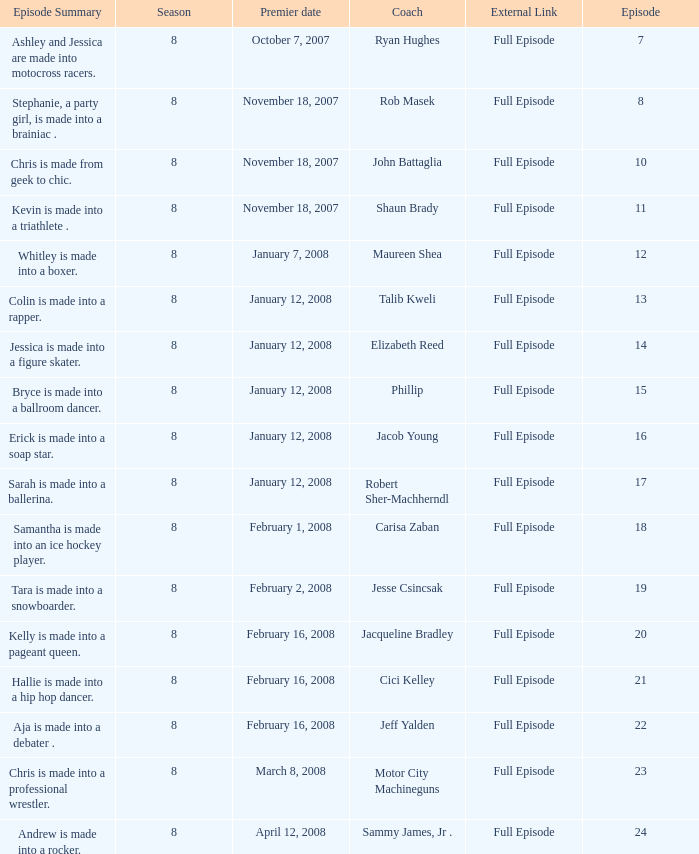Which maximum episode made its debut on march 8, 2008? 23.0. 